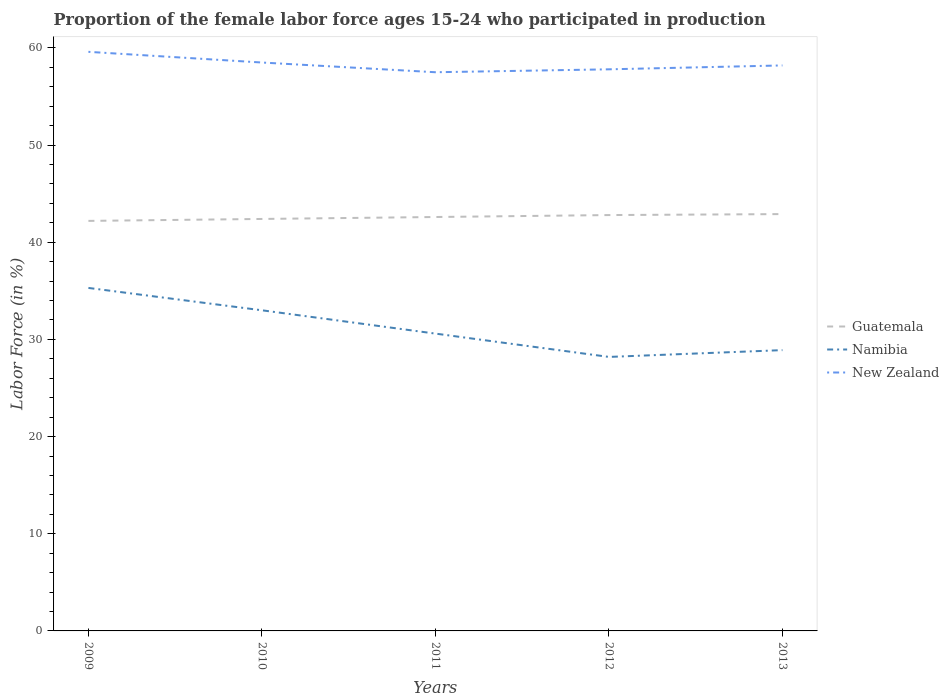Does the line corresponding to Namibia intersect with the line corresponding to Guatemala?
Your response must be concise. No. Is the number of lines equal to the number of legend labels?
Your answer should be very brief. Yes. Across all years, what is the maximum proportion of the female labor force who participated in production in Guatemala?
Keep it short and to the point. 42.2. What is the total proportion of the female labor force who participated in production in New Zealand in the graph?
Make the answer very short. 1.8. What is the difference between the highest and the second highest proportion of the female labor force who participated in production in New Zealand?
Offer a terse response. 2.1. What is the difference between the highest and the lowest proportion of the female labor force who participated in production in New Zealand?
Offer a terse response. 2. How many lines are there?
Give a very brief answer. 3. What is the difference between two consecutive major ticks on the Y-axis?
Keep it short and to the point. 10. How many legend labels are there?
Your answer should be very brief. 3. What is the title of the graph?
Your answer should be very brief. Proportion of the female labor force ages 15-24 who participated in production. Does "Cote d'Ivoire" appear as one of the legend labels in the graph?
Provide a succinct answer. No. What is the label or title of the X-axis?
Make the answer very short. Years. What is the label or title of the Y-axis?
Give a very brief answer. Labor Force (in %). What is the Labor Force (in %) of Guatemala in 2009?
Provide a succinct answer. 42.2. What is the Labor Force (in %) in Namibia in 2009?
Provide a short and direct response. 35.3. What is the Labor Force (in %) in New Zealand in 2009?
Keep it short and to the point. 59.6. What is the Labor Force (in %) of Guatemala in 2010?
Provide a succinct answer. 42.4. What is the Labor Force (in %) in New Zealand in 2010?
Your response must be concise. 58.5. What is the Labor Force (in %) of Guatemala in 2011?
Provide a short and direct response. 42.6. What is the Labor Force (in %) of Namibia in 2011?
Offer a very short reply. 30.6. What is the Labor Force (in %) of New Zealand in 2011?
Provide a short and direct response. 57.5. What is the Labor Force (in %) of Guatemala in 2012?
Give a very brief answer. 42.8. What is the Labor Force (in %) of Namibia in 2012?
Ensure brevity in your answer.  28.2. What is the Labor Force (in %) of New Zealand in 2012?
Provide a short and direct response. 57.8. What is the Labor Force (in %) of Guatemala in 2013?
Provide a succinct answer. 42.9. What is the Labor Force (in %) in Namibia in 2013?
Make the answer very short. 28.9. What is the Labor Force (in %) in New Zealand in 2013?
Give a very brief answer. 58.2. Across all years, what is the maximum Labor Force (in %) in Guatemala?
Your answer should be very brief. 42.9. Across all years, what is the maximum Labor Force (in %) in Namibia?
Give a very brief answer. 35.3. Across all years, what is the maximum Labor Force (in %) of New Zealand?
Provide a succinct answer. 59.6. Across all years, what is the minimum Labor Force (in %) in Guatemala?
Offer a terse response. 42.2. Across all years, what is the minimum Labor Force (in %) in Namibia?
Provide a succinct answer. 28.2. Across all years, what is the minimum Labor Force (in %) in New Zealand?
Give a very brief answer. 57.5. What is the total Labor Force (in %) in Guatemala in the graph?
Your answer should be very brief. 212.9. What is the total Labor Force (in %) in Namibia in the graph?
Your response must be concise. 156. What is the total Labor Force (in %) in New Zealand in the graph?
Your response must be concise. 291.6. What is the difference between the Labor Force (in %) of Namibia in 2009 and that in 2010?
Your answer should be very brief. 2.3. What is the difference between the Labor Force (in %) of New Zealand in 2009 and that in 2011?
Your answer should be very brief. 2.1. What is the difference between the Labor Force (in %) in Guatemala in 2009 and that in 2012?
Keep it short and to the point. -0.6. What is the difference between the Labor Force (in %) of New Zealand in 2009 and that in 2012?
Provide a succinct answer. 1.8. What is the difference between the Labor Force (in %) in Namibia in 2009 and that in 2013?
Your answer should be compact. 6.4. What is the difference between the Labor Force (in %) in Guatemala in 2010 and that in 2011?
Provide a succinct answer. -0.2. What is the difference between the Labor Force (in %) of Guatemala in 2010 and that in 2013?
Your response must be concise. -0.5. What is the difference between the Labor Force (in %) of New Zealand in 2010 and that in 2013?
Provide a short and direct response. 0.3. What is the difference between the Labor Force (in %) of Namibia in 2011 and that in 2012?
Ensure brevity in your answer.  2.4. What is the difference between the Labor Force (in %) in New Zealand in 2011 and that in 2012?
Ensure brevity in your answer.  -0.3. What is the difference between the Labor Force (in %) in New Zealand in 2011 and that in 2013?
Your answer should be very brief. -0.7. What is the difference between the Labor Force (in %) in Guatemala in 2012 and that in 2013?
Offer a terse response. -0.1. What is the difference between the Labor Force (in %) in Namibia in 2012 and that in 2013?
Ensure brevity in your answer.  -0.7. What is the difference between the Labor Force (in %) in New Zealand in 2012 and that in 2013?
Keep it short and to the point. -0.4. What is the difference between the Labor Force (in %) of Guatemala in 2009 and the Labor Force (in %) of Namibia in 2010?
Offer a terse response. 9.2. What is the difference between the Labor Force (in %) of Guatemala in 2009 and the Labor Force (in %) of New Zealand in 2010?
Ensure brevity in your answer.  -16.3. What is the difference between the Labor Force (in %) of Namibia in 2009 and the Labor Force (in %) of New Zealand in 2010?
Your response must be concise. -23.2. What is the difference between the Labor Force (in %) of Guatemala in 2009 and the Labor Force (in %) of New Zealand in 2011?
Your answer should be compact. -15.3. What is the difference between the Labor Force (in %) of Namibia in 2009 and the Labor Force (in %) of New Zealand in 2011?
Offer a very short reply. -22.2. What is the difference between the Labor Force (in %) of Guatemala in 2009 and the Labor Force (in %) of Namibia in 2012?
Make the answer very short. 14. What is the difference between the Labor Force (in %) of Guatemala in 2009 and the Labor Force (in %) of New Zealand in 2012?
Make the answer very short. -15.6. What is the difference between the Labor Force (in %) of Namibia in 2009 and the Labor Force (in %) of New Zealand in 2012?
Give a very brief answer. -22.5. What is the difference between the Labor Force (in %) of Guatemala in 2009 and the Labor Force (in %) of Namibia in 2013?
Make the answer very short. 13.3. What is the difference between the Labor Force (in %) of Guatemala in 2009 and the Labor Force (in %) of New Zealand in 2013?
Provide a succinct answer. -16. What is the difference between the Labor Force (in %) of Namibia in 2009 and the Labor Force (in %) of New Zealand in 2013?
Provide a short and direct response. -22.9. What is the difference between the Labor Force (in %) of Guatemala in 2010 and the Labor Force (in %) of New Zealand in 2011?
Your answer should be very brief. -15.1. What is the difference between the Labor Force (in %) in Namibia in 2010 and the Labor Force (in %) in New Zealand in 2011?
Your response must be concise. -24.5. What is the difference between the Labor Force (in %) of Guatemala in 2010 and the Labor Force (in %) of New Zealand in 2012?
Ensure brevity in your answer.  -15.4. What is the difference between the Labor Force (in %) of Namibia in 2010 and the Labor Force (in %) of New Zealand in 2012?
Offer a very short reply. -24.8. What is the difference between the Labor Force (in %) in Guatemala in 2010 and the Labor Force (in %) in New Zealand in 2013?
Keep it short and to the point. -15.8. What is the difference between the Labor Force (in %) of Namibia in 2010 and the Labor Force (in %) of New Zealand in 2013?
Make the answer very short. -25.2. What is the difference between the Labor Force (in %) in Guatemala in 2011 and the Labor Force (in %) in New Zealand in 2012?
Your answer should be compact. -15.2. What is the difference between the Labor Force (in %) of Namibia in 2011 and the Labor Force (in %) of New Zealand in 2012?
Ensure brevity in your answer.  -27.2. What is the difference between the Labor Force (in %) of Guatemala in 2011 and the Labor Force (in %) of New Zealand in 2013?
Ensure brevity in your answer.  -15.6. What is the difference between the Labor Force (in %) of Namibia in 2011 and the Labor Force (in %) of New Zealand in 2013?
Provide a succinct answer. -27.6. What is the difference between the Labor Force (in %) in Guatemala in 2012 and the Labor Force (in %) in New Zealand in 2013?
Provide a succinct answer. -15.4. What is the average Labor Force (in %) of Guatemala per year?
Provide a succinct answer. 42.58. What is the average Labor Force (in %) of Namibia per year?
Your response must be concise. 31.2. What is the average Labor Force (in %) in New Zealand per year?
Your answer should be compact. 58.32. In the year 2009, what is the difference between the Labor Force (in %) of Guatemala and Labor Force (in %) of New Zealand?
Your answer should be compact. -17.4. In the year 2009, what is the difference between the Labor Force (in %) of Namibia and Labor Force (in %) of New Zealand?
Keep it short and to the point. -24.3. In the year 2010, what is the difference between the Labor Force (in %) of Guatemala and Labor Force (in %) of New Zealand?
Make the answer very short. -16.1. In the year 2010, what is the difference between the Labor Force (in %) in Namibia and Labor Force (in %) in New Zealand?
Provide a succinct answer. -25.5. In the year 2011, what is the difference between the Labor Force (in %) of Guatemala and Labor Force (in %) of New Zealand?
Keep it short and to the point. -14.9. In the year 2011, what is the difference between the Labor Force (in %) of Namibia and Labor Force (in %) of New Zealand?
Make the answer very short. -26.9. In the year 2012, what is the difference between the Labor Force (in %) of Namibia and Labor Force (in %) of New Zealand?
Your answer should be very brief. -29.6. In the year 2013, what is the difference between the Labor Force (in %) in Guatemala and Labor Force (in %) in Namibia?
Your answer should be very brief. 14. In the year 2013, what is the difference between the Labor Force (in %) in Guatemala and Labor Force (in %) in New Zealand?
Offer a very short reply. -15.3. In the year 2013, what is the difference between the Labor Force (in %) of Namibia and Labor Force (in %) of New Zealand?
Offer a terse response. -29.3. What is the ratio of the Labor Force (in %) in Guatemala in 2009 to that in 2010?
Provide a short and direct response. 1. What is the ratio of the Labor Force (in %) in Namibia in 2009 to that in 2010?
Offer a terse response. 1.07. What is the ratio of the Labor Force (in %) in New Zealand in 2009 to that in 2010?
Ensure brevity in your answer.  1.02. What is the ratio of the Labor Force (in %) in Guatemala in 2009 to that in 2011?
Your answer should be very brief. 0.99. What is the ratio of the Labor Force (in %) in Namibia in 2009 to that in 2011?
Your answer should be compact. 1.15. What is the ratio of the Labor Force (in %) of New Zealand in 2009 to that in 2011?
Offer a very short reply. 1.04. What is the ratio of the Labor Force (in %) of Namibia in 2009 to that in 2012?
Offer a terse response. 1.25. What is the ratio of the Labor Force (in %) of New Zealand in 2009 to that in 2012?
Provide a short and direct response. 1.03. What is the ratio of the Labor Force (in %) of Guatemala in 2009 to that in 2013?
Offer a terse response. 0.98. What is the ratio of the Labor Force (in %) in Namibia in 2009 to that in 2013?
Your answer should be very brief. 1.22. What is the ratio of the Labor Force (in %) of New Zealand in 2009 to that in 2013?
Keep it short and to the point. 1.02. What is the ratio of the Labor Force (in %) of Guatemala in 2010 to that in 2011?
Your response must be concise. 1. What is the ratio of the Labor Force (in %) of Namibia in 2010 to that in 2011?
Offer a very short reply. 1.08. What is the ratio of the Labor Force (in %) of New Zealand in 2010 to that in 2011?
Offer a very short reply. 1.02. What is the ratio of the Labor Force (in %) in Namibia in 2010 to that in 2012?
Ensure brevity in your answer.  1.17. What is the ratio of the Labor Force (in %) in New Zealand in 2010 to that in 2012?
Make the answer very short. 1.01. What is the ratio of the Labor Force (in %) in Guatemala in 2010 to that in 2013?
Your response must be concise. 0.99. What is the ratio of the Labor Force (in %) in Namibia in 2010 to that in 2013?
Provide a short and direct response. 1.14. What is the ratio of the Labor Force (in %) in New Zealand in 2010 to that in 2013?
Offer a very short reply. 1.01. What is the ratio of the Labor Force (in %) in Namibia in 2011 to that in 2012?
Your answer should be compact. 1.09. What is the ratio of the Labor Force (in %) of Namibia in 2011 to that in 2013?
Offer a terse response. 1.06. What is the ratio of the Labor Force (in %) of Guatemala in 2012 to that in 2013?
Ensure brevity in your answer.  1. What is the ratio of the Labor Force (in %) of Namibia in 2012 to that in 2013?
Provide a short and direct response. 0.98. What is the difference between the highest and the second highest Labor Force (in %) in Guatemala?
Provide a short and direct response. 0.1. What is the difference between the highest and the second highest Labor Force (in %) of New Zealand?
Give a very brief answer. 1.1. 